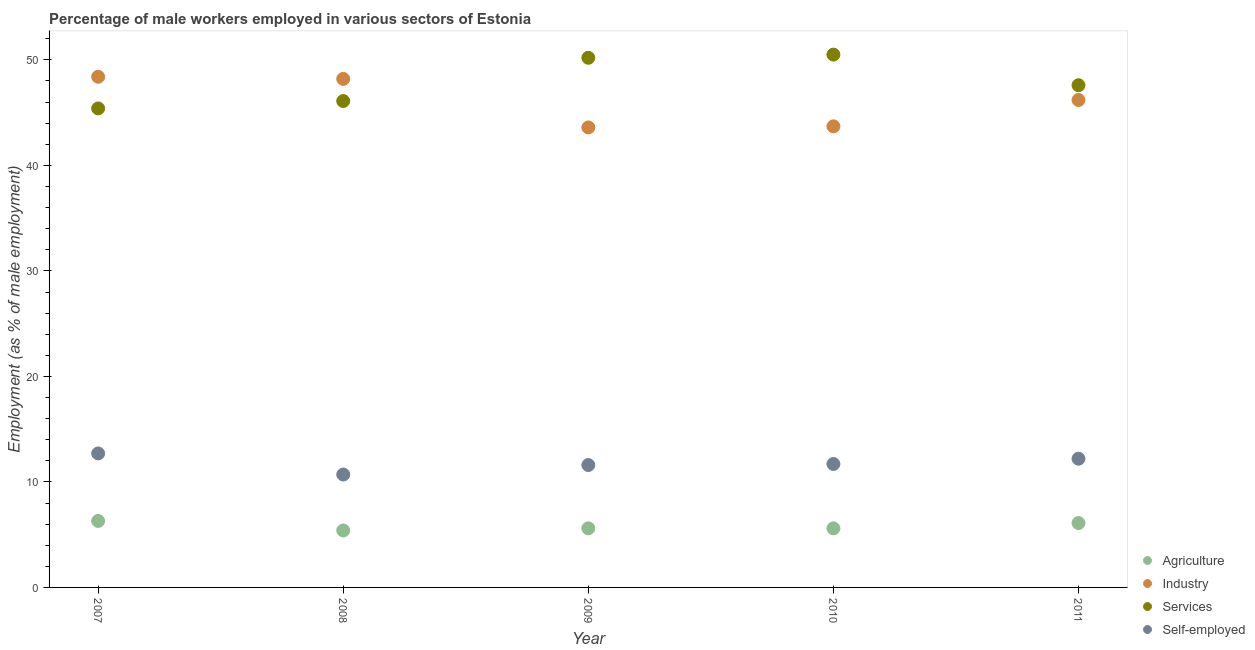Is the number of dotlines equal to the number of legend labels?
Offer a very short reply. Yes. What is the percentage of male workers in agriculture in 2007?
Provide a short and direct response. 6.3. Across all years, what is the maximum percentage of male workers in services?
Make the answer very short. 50.5. Across all years, what is the minimum percentage of male workers in services?
Ensure brevity in your answer.  45.4. What is the total percentage of self employed male workers in the graph?
Keep it short and to the point. 58.9. What is the difference between the percentage of male workers in agriculture in 2008 and that in 2010?
Provide a succinct answer. -0.2. What is the difference between the percentage of male workers in industry in 2010 and the percentage of male workers in services in 2009?
Keep it short and to the point. -6.5. What is the average percentage of male workers in services per year?
Keep it short and to the point. 47.96. In the year 2007, what is the difference between the percentage of male workers in agriculture and percentage of self employed male workers?
Offer a terse response. -6.4. In how many years, is the percentage of male workers in industry greater than 38 %?
Provide a succinct answer. 5. What is the ratio of the percentage of male workers in agriculture in 2010 to that in 2011?
Provide a short and direct response. 0.92. What is the difference between the highest and the second highest percentage of male workers in agriculture?
Give a very brief answer. 0.2. What is the difference between the highest and the lowest percentage of male workers in industry?
Keep it short and to the point. 4.8. Is the sum of the percentage of male workers in services in 2007 and 2008 greater than the maximum percentage of male workers in agriculture across all years?
Offer a terse response. Yes. Is it the case that in every year, the sum of the percentage of male workers in services and percentage of male workers in agriculture is greater than the sum of percentage of self employed male workers and percentage of male workers in industry?
Keep it short and to the point. Yes. Does the percentage of male workers in services monotonically increase over the years?
Offer a very short reply. No. How many dotlines are there?
Your answer should be compact. 4. How many years are there in the graph?
Give a very brief answer. 5. What is the difference between two consecutive major ticks on the Y-axis?
Ensure brevity in your answer.  10. Does the graph contain grids?
Your response must be concise. No. Where does the legend appear in the graph?
Your answer should be compact. Bottom right. How many legend labels are there?
Keep it short and to the point. 4. What is the title of the graph?
Offer a terse response. Percentage of male workers employed in various sectors of Estonia. Does "Quality of public administration" appear as one of the legend labels in the graph?
Provide a succinct answer. No. What is the label or title of the X-axis?
Provide a short and direct response. Year. What is the label or title of the Y-axis?
Your response must be concise. Employment (as % of male employment). What is the Employment (as % of male employment) in Agriculture in 2007?
Offer a terse response. 6.3. What is the Employment (as % of male employment) of Industry in 2007?
Provide a short and direct response. 48.4. What is the Employment (as % of male employment) of Services in 2007?
Make the answer very short. 45.4. What is the Employment (as % of male employment) in Self-employed in 2007?
Keep it short and to the point. 12.7. What is the Employment (as % of male employment) of Agriculture in 2008?
Offer a very short reply. 5.4. What is the Employment (as % of male employment) of Industry in 2008?
Provide a short and direct response. 48.2. What is the Employment (as % of male employment) in Services in 2008?
Make the answer very short. 46.1. What is the Employment (as % of male employment) of Self-employed in 2008?
Provide a short and direct response. 10.7. What is the Employment (as % of male employment) of Agriculture in 2009?
Your answer should be compact. 5.6. What is the Employment (as % of male employment) in Industry in 2009?
Give a very brief answer. 43.6. What is the Employment (as % of male employment) in Services in 2009?
Your answer should be compact. 50.2. What is the Employment (as % of male employment) in Self-employed in 2009?
Provide a succinct answer. 11.6. What is the Employment (as % of male employment) in Agriculture in 2010?
Your answer should be compact. 5.6. What is the Employment (as % of male employment) of Industry in 2010?
Offer a terse response. 43.7. What is the Employment (as % of male employment) in Services in 2010?
Provide a succinct answer. 50.5. What is the Employment (as % of male employment) in Self-employed in 2010?
Give a very brief answer. 11.7. What is the Employment (as % of male employment) in Agriculture in 2011?
Your response must be concise. 6.1. What is the Employment (as % of male employment) in Industry in 2011?
Your answer should be very brief. 46.2. What is the Employment (as % of male employment) in Services in 2011?
Your answer should be very brief. 47.6. What is the Employment (as % of male employment) of Self-employed in 2011?
Give a very brief answer. 12.2. Across all years, what is the maximum Employment (as % of male employment) in Agriculture?
Make the answer very short. 6.3. Across all years, what is the maximum Employment (as % of male employment) in Industry?
Your answer should be compact. 48.4. Across all years, what is the maximum Employment (as % of male employment) of Services?
Offer a very short reply. 50.5. Across all years, what is the maximum Employment (as % of male employment) of Self-employed?
Provide a succinct answer. 12.7. Across all years, what is the minimum Employment (as % of male employment) of Agriculture?
Provide a succinct answer. 5.4. Across all years, what is the minimum Employment (as % of male employment) of Industry?
Your response must be concise. 43.6. Across all years, what is the minimum Employment (as % of male employment) in Services?
Keep it short and to the point. 45.4. Across all years, what is the minimum Employment (as % of male employment) in Self-employed?
Provide a succinct answer. 10.7. What is the total Employment (as % of male employment) of Agriculture in the graph?
Ensure brevity in your answer.  29. What is the total Employment (as % of male employment) in Industry in the graph?
Give a very brief answer. 230.1. What is the total Employment (as % of male employment) in Services in the graph?
Make the answer very short. 239.8. What is the total Employment (as % of male employment) of Self-employed in the graph?
Ensure brevity in your answer.  58.9. What is the difference between the Employment (as % of male employment) in Agriculture in 2007 and that in 2008?
Your answer should be very brief. 0.9. What is the difference between the Employment (as % of male employment) in Industry in 2007 and that in 2008?
Your answer should be compact. 0.2. What is the difference between the Employment (as % of male employment) of Self-employed in 2007 and that in 2010?
Keep it short and to the point. 1. What is the difference between the Employment (as % of male employment) of Industry in 2007 and that in 2011?
Your response must be concise. 2.2. What is the difference between the Employment (as % of male employment) of Industry in 2008 and that in 2009?
Offer a terse response. 4.6. What is the difference between the Employment (as % of male employment) of Industry in 2008 and that in 2010?
Offer a very short reply. 4.5. What is the difference between the Employment (as % of male employment) of Services in 2008 and that in 2010?
Provide a short and direct response. -4.4. What is the difference between the Employment (as % of male employment) in Self-employed in 2008 and that in 2010?
Your answer should be very brief. -1. What is the difference between the Employment (as % of male employment) of Agriculture in 2008 and that in 2011?
Offer a very short reply. -0.7. What is the difference between the Employment (as % of male employment) in Services in 2008 and that in 2011?
Provide a succinct answer. -1.5. What is the difference between the Employment (as % of male employment) in Agriculture in 2009 and that in 2010?
Provide a short and direct response. 0. What is the difference between the Employment (as % of male employment) in Industry in 2009 and that in 2010?
Provide a short and direct response. -0.1. What is the difference between the Employment (as % of male employment) of Services in 2009 and that in 2010?
Your response must be concise. -0.3. What is the difference between the Employment (as % of male employment) in Agriculture in 2009 and that in 2011?
Your answer should be compact. -0.5. What is the difference between the Employment (as % of male employment) in Industry in 2009 and that in 2011?
Provide a short and direct response. -2.6. What is the difference between the Employment (as % of male employment) of Self-employed in 2010 and that in 2011?
Make the answer very short. -0.5. What is the difference between the Employment (as % of male employment) of Agriculture in 2007 and the Employment (as % of male employment) of Industry in 2008?
Offer a terse response. -41.9. What is the difference between the Employment (as % of male employment) of Agriculture in 2007 and the Employment (as % of male employment) of Services in 2008?
Provide a short and direct response. -39.8. What is the difference between the Employment (as % of male employment) in Agriculture in 2007 and the Employment (as % of male employment) in Self-employed in 2008?
Give a very brief answer. -4.4. What is the difference between the Employment (as % of male employment) of Industry in 2007 and the Employment (as % of male employment) of Services in 2008?
Provide a succinct answer. 2.3. What is the difference between the Employment (as % of male employment) of Industry in 2007 and the Employment (as % of male employment) of Self-employed in 2008?
Give a very brief answer. 37.7. What is the difference between the Employment (as % of male employment) in Services in 2007 and the Employment (as % of male employment) in Self-employed in 2008?
Ensure brevity in your answer.  34.7. What is the difference between the Employment (as % of male employment) in Agriculture in 2007 and the Employment (as % of male employment) in Industry in 2009?
Ensure brevity in your answer.  -37.3. What is the difference between the Employment (as % of male employment) in Agriculture in 2007 and the Employment (as % of male employment) in Services in 2009?
Keep it short and to the point. -43.9. What is the difference between the Employment (as % of male employment) of Agriculture in 2007 and the Employment (as % of male employment) of Self-employed in 2009?
Your answer should be very brief. -5.3. What is the difference between the Employment (as % of male employment) of Industry in 2007 and the Employment (as % of male employment) of Self-employed in 2009?
Provide a succinct answer. 36.8. What is the difference between the Employment (as % of male employment) of Services in 2007 and the Employment (as % of male employment) of Self-employed in 2009?
Your answer should be compact. 33.8. What is the difference between the Employment (as % of male employment) of Agriculture in 2007 and the Employment (as % of male employment) of Industry in 2010?
Your response must be concise. -37.4. What is the difference between the Employment (as % of male employment) in Agriculture in 2007 and the Employment (as % of male employment) in Services in 2010?
Make the answer very short. -44.2. What is the difference between the Employment (as % of male employment) of Agriculture in 2007 and the Employment (as % of male employment) of Self-employed in 2010?
Your answer should be compact. -5.4. What is the difference between the Employment (as % of male employment) in Industry in 2007 and the Employment (as % of male employment) in Services in 2010?
Give a very brief answer. -2.1. What is the difference between the Employment (as % of male employment) in Industry in 2007 and the Employment (as % of male employment) in Self-employed in 2010?
Offer a very short reply. 36.7. What is the difference between the Employment (as % of male employment) of Services in 2007 and the Employment (as % of male employment) of Self-employed in 2010?
Offer a very short reply. 33.7. What is the difference between the Employment (as % of male employment) in Agriculture in 2007 and the Employment (as % of male employment) in Industry in 2011?
Keep it short and to the point. -39.9. What is the difference between the Employment (as % of male employment) in Agriculture in 2007 and the Employment (as % of male employment) in Services in 2011?
Offer a very short reply. -41.3. What is the difference between the Employment (as % of male employment) of Industry in 2007 and the Employment (as % of male employment) of Services in 2011?
Provide a succinct answer. 0.8. What is the difference between the Employment (as % of male employment) of Industry in 2007 and the Employment (as % of male employment) of Self-employed in 2011?
Your answer should be compact. 36.2. What is the difference between the Employment (as % of male employment) of Services in 2007 and the Employment (as % of male employment) of Self-employed in 2011?
Make the answer very short. 33.2. What is the difference between the Employment (as % of male employment) in Agriculture in 2008 and the Employment (as % of male employment) in Industry in 2009?
Make the answer very short. -38.2. What is the difference between the Employment (as % of male employment) in Agriculture in 2008 and the Employment (as % of male employment) in Services in 2009?
Provide a short and direct response. -44.8. What is the difference between the Employment (as % of male employment) in Agriculture in 2008 and the Employment (as % of male employment) in Self-employed in 2009?
Your answer should be compact. -6.2. What is the difference between the Employment (as % of male employment) of Industry in 2008 and the Employment (as % of male employment) of Self-employed in 2009?
Make the answer very short. 36.6. What is the difference between the Employment (as % of male employment) in Services in 2008 and the Employment (as % of male employment) in Self-employed in 2009?
Make the answer very short. 34.5. What is the difference between the Employment (as % of male employment) of Agriculture in 2008 and the Employment (as % of male employment) of Industry in 2010?
Your answer should be very brief. -38.3. What is the difference between the Employment (as % of male employment) in Agriculture in 2008 and the Employment (as % of male employment) in Services in 2010?
Provide a succinct answer. -45.1. What is the difference between the Employment (as % of male employment) in Agriculture in 2008 and the Employment (as % of male employment) in Self-employed in 2010?
Your answer should be very brief. -6.3. What is the difference between the Employment (as % of male employment) in Industry in 2008 and the Employment (as % of male employment) in Services in 2010?
Make the answer very short. -2.3. What is the difference between the Employment (as % of male employment) of Industry in 2008 and the Employment (as % of male employment) of Self-employed in 2010?
Your answer should be compact. 36.5. What is the difference between the Employment (as % of male employment) in Services in 2008 and the Employment (as % of male employment) in Self-employed in 2010?
Offer a terse response. 34.4. What is the difference between the Employment (as % of male employment) of Agriculture in 2008 and the Employment (as % of male employment) of Industry in 2011?
Provide a short and direct response. -40.8. What is the difference between the Employment (as % of male employment) of Agriculture in 2008 and the Employment (as % of male employment) of Services in 2011?
Your answer should be compact. -42.2. What is the difference between the Employment (as % of male employment) of Agriculture in 2008 and the Employment (as % of male employment) of Self-employed in 2011?
Keep it short and to the point. -6.8. What is the difference between the Employment (as % of male employment) of Industry in 2008 and the Employment (as % of male employment) of Services in 2011?
Provide a short and direct response. 0.6. What is the difference between the Employment (as % of male employment) of Services in 2008 and the Employment (as % of male employment) of Self-employed in 2011?
Your response must be concise. 33.9. What is the difference between the Employment (as % of male employment) in Agriculture in 2009 and the Employment (as % of male employment) in Industry in 2010?
Keep it short and to the point. -38.1. What is the difference between the Employment (as % of male employment) of Agriculture in 2009 and the Employment (as % of male employment) of Services in 2010?
Ensure brevity in your answer.  -44.9. What is the difference between the Employment (as % of male employment) in Industry in 2009 and the Employment (as % of male employment) in Services in 2010?
Your response must be concise. -6.9. What is the difference between the Employment (as % of male employment) of Industry in 2009 and the Employment (as % of male employment) of Self-employed in 2010?
Ensure brevity in your answer.  31.9. What is the difference between the Employment (as % of male employment) of Services in 2009 and the Employment (as % of male employment) of Self-employed in 2010?
Make the answer very short. 38.5. What is the difference between the Employment (as % of male employment) in Agriculture in 2009 and the Employment (as % of male employment) in Industry in 2011?
Ensure brevity in your answer.  -40.6. What is the difference between the Employment (as % of male employment) of Agriculture in 2009 and the Employment (as % of male employment) of Services in 2011?
Provide a short and direct response. -42. What is the difference between the Employment (as % of male employment) in Agriculture in 2009 and the Employment (as % of male employment) in Self-employed in 2011?
Your answer should be compact. -6.6. What is the difference between the Employment (as % of male employment) of Industry in 2009 and the Employment (as % of male employment) of Self-employed in 2011?
Offer a very short reply. 31.4. What is the difference between the Employment (as % of male employment) of Services in 2009 and the Employment (as % of male employment) of Self-employed in 2011?
Your answer should be very brief. 38. What is the difference between the Employment (as % of male employment) of Agriculture in 2010 and the Employment (as % of male employment) of Industry in 2011?
Your answer should be very brief. -40.6. What is the difference between the Employment (as % of male employment) in Agriculture in 2010 and the Employment (as % of male employment) in Services in 2011?
Your answer should be very brief. -42. What is the difference between the Employment (as % of male employment) of Agriculture in 2010 and the Employment (as % of male employment) of Self-employed in 2011?
Your answer should be very brief. -6.6. What is the difference between the Employment (as % of male employment) in Industry in 2010 and the Employment (as % of male employment) in Services in 2011?
Give a very brief answer. -3.9. What is the difference between the Employment (as % of male employment) of Industry in 2010 and the Employment (as % of male employment) of Self-employed in 2011?
Provide a short and direct response. 31.5. What is the difference between the Employment (as % of male employment) of Services in 2010 and the Employment (as % of male employment) of Self-employed in 2011?
Keep it short and to the point. 38.3. What is the average Employment (as % of male employment) of Agriculture per year?
Keep it short and to the point. 5.8. What is the average Employment (as % of male employment) in Industry per year?
Make the answer very short. 46.02. What is the average Employment (as % of male employment) in Services per year?
Your response must be concise. 47.96. What is the average Employment (as % of male employment) of Self-employed per year?
Offer a very short reply. 11.78. In the year 2007, what is the difference between the Employment (as % of male employment) in Agriculture and Employment (as % of male employment) in Industry?
Provide a succinct answer. -42.1. In the year 2007, what is the difference between the Employment (as % of male employment) of Agriculture and Employment (as % of male employment) of Services?
Give a very brief answer. -39.1. In the year 2007, what is the difference between the Employment (as % of male employment) in Industry and Employment (as % of male employment) in Services?
Offer a very short reply. 3. In the year 2007, what is the difference between the Employment (as % of male employment) in Industry and Employment (as % of male employment) in Self-employed?
Your answer should be very brief. 35.7. In the year 2007, what is the difference between the Employment (as % of male employment) of Services and Employment (as % of male employment) of Self-employed?
Offer a terse response. 32.7. In the year 2008, what is the difference between the Employment (as % of male employment) in Agriculture and Employment (as % of male employment) in Industry?
Offer a very short reply. -42.8. In the year 2008, what is the difference between the Employment (as % of male employment) in Agriculture and Employment (as % of male employment) in Services?
Offer a terse response. -40.7. In the year 2008, what is the difference between the Employment (as % of male employment) in Agriculture and Employment (as % of male employment) in Self-employed?
Offer a very short reply. -5.3. In the year 2008, what is the difference between the Employment (as % of male employment) in Industry and Employment (as % of male employment) in Self-employed?
Offer a terse response. 37.5. In the year 2008, what is the difference between the Employment (as % of male employment) in Services and Employment (as % of male employment) in Self-employed?
Offer a terse response. 35.4. In the year 2009, what is the difference between the Employment (as % of male employment) of Agriculture and Employment (as % of male employment) of Industry?
Ensure brevity in your answer.  -38. In the year 2009, what is the difference between the Employment (as % of male employment) of Agriculture and Employment (as % of male employment) of Services?
Provide a succinct answer. -44.6. In the year 2009, what is the difference between the Employment (as % of male employment) of Agriculture and Employment (as % of male employment) of Self-employed?
Keep it short and to the point. -6. In the year 2009, what is the difference between the Employment (as % of male employment) in Industry and Employment (as % of male employment) in Services?
Keep it short and to the point. -6.6. In the year 2009, what is the difference between the Employment (as % of male employment) of Industry and Employment (as % of male employment) of Self-employed?
Your answer should be compact. 32. In the year 2009, what is the difference between the Employment (as % of male employment) of Services and Employment (as % of male employment) of Self-employed?
Offer a very short reply. 38.6. In the year 2010, what is the difference between the Employment (as % of male employment) of Agriculture and Employment (as % of male employment) of Industry?
Keep it short and to the point. -38.1. In the year 2010, what is the difference between the Employment (as % of male employment) of Agriculture and Employment (as % of male employment) of Services?
Your answer should be compact. -44.9. In the year 2010, what is the difference between the Employment (as % of male employment) in Services and Employment (as % of male employment) in Self-employed?
Your response must be concise. 38.8. In the year 2011, what is the difference between the Employment (as % of male employment) of Agriculture and Employment (as % of male employment) of Industry?
Provide a short and direct response. -40.1. In the year 2011, what is the difference between the Employment (as % of male employment) in Agriculture and Employment (as % of male employment) in Services?
Make the answer very short. -41.5. In the year 2011, what is the difference between the Employment (as % of male employment) of Agriculture and Employment (as % of male employment) of Self-employed?
Your response must be concise. -6.1. In the year 2011, what is the difference between the Employment (as % of male employment) of Industry and Employment (as % of male employment) of Services?
Keep it short and to the point. -1.4. In the year 2011, what is the difference between the Employment (as % of male employment) in Industry and Employment (as % of male employment) in Self-employed?
Your answer should be compact. 34. In the year 2011, what is the difference between the Employment (as % of male employment) of Services and Employment (as % of male employment) of Self-employed?
Your answer should be very brief. 35.4. What is the ratio of the Employment (as % of male employment) of Self-employed in 2007 to that in 2008?
Keep it short and to the point. 1.19. What is the ratio of the Employment (as % of male employment) in Industry in 2007 to that in 2009?
Offer a terse response. 1.11. What is the ratio of the Employment (as % of male employment) of Services in 2007 to that in 2009?
Offer a very short reply. 0.9. What is the ratio of the Employment (as % of male employment) in Self-employed in 2007 to that in 2009?
Your response must be concise. 1.09. What is the ratio of the Employment (as % of male employment) in Industry in 2007 to that in 2010?
Your answer should be compact. 1.11. What is the ratio of the Employment (as % of male employment) in Services in 2007 to that in 2010?
Keep it short and to the point. 0.9. What is the ratio of the Employment (as % of male employment) in Self-employed in 2007 to that in 2010?
Offer a very short reply. 1.09. What is the ratio of the Employment (as % of male employment) in Agriculture in 2007 to that in 2011?
Your answer should be compact. 1.03. What is the ratio of the Employment (as % of male employment) in Industry in 2007 to that in 2011?
Your response must be concise. 1.05. What is the ratio of the Employment (as % of male employment) in Services in 2007 to that in 2011?
Make the answer very short. 0.95. What is the ratio of the Employment (as % of male employment) of Self-employed in 2007 to that in 2011?
Offer a very short reply. 1.04. What is the ratio of the Employment (as % of male employment) in Industry in 2008 to that in 2009?
Ensure brevity in your answer.  1.11. What is the ratio of the Employment (as % of male employment) in Services in 2008 to that in 2009?
Your answer should be compact. 0.92. What is the ratio of the Employment (as % of male employment) in Self-employed in 2008 to that in 2009?
Your answer should be compact. 0.92. What is the ratio of the Employment (as % of male employment) of Industry in 2008 to that in 2010?
Make the answer very short. 1.1. What is the ratio of the Employment (as % of male employment) of Services in 2008 to that in 2010?
Give a very brief answer. 0.91. What is the ratio of the Employment (as % of male employment) in Self-employed in 2008 to that in 2010?
Offer a terse response. 0.91. What is the ratio of the Employment (as % of male employment) of Agriculture in 2008 to that in 2011?
Ensure brevity in your answer.  0.89. What is the ratio of the Employment (as % of male employment) of Industry in 2008 to that in 2011?
Your answer should be compact. 1.04. What is the ratio of the Employment (as % of male employment) of Services in 2008 to that in 2011?
Your answer should be compact. 0.97. What is the ratio of the Employment (as % of male employment) in Self-employed in 2008 to that in 2011?
Your answer should be compact. 0.88. What is the ratio of the Employment (as % of male employment) in Agriculture in 2009 to that in 2010?
Offer a terse response. 1. What is the ratio of the Employment (as % of male employment) in Industry in 2009 to that in 2010?
Your response must be concise. 1. What is the ratio of the Employment (as % of male employment) of Services in 2009 to that in 2010?
Your answer should be very brief. 0.99. What is the ratio of the Employment (as % of male employment) in Agriculture in 2009 to that in 2011?
Your answer should be compact. 0.92. What is the ratio of the Employment (as % of male employment) in Industry in 2009 to that in 2011?
Provide a short and direct response. 0.94. What is the ratio of the Employment (as % of male employment) in Services in 2009 to that in 2011?
Your response must be concise. 1.05. What is the ratio of the Employment (as % of male employment) in Self-employed in 2009 to that in 2011?
Make the answer very short. 0.95. What is the ratio of the Employment (as % of male employment) of Agriculture in 2010 to that in 2011?
Ensure brevity in your answer.  0.92. What is the ratio of the Employment (as % of male employment) of Industry in 2010 to that in 2011?
Offer a very short reply. 0.95. What is the ratio of the Employment (as % of male employment) in Services in 2010 to that in 2011?
Provide a short and direct response. 1.06. What is the ratio of the Employment (as % of male employment) of Self-employed in 2010 to that in 2011?
Your answer should be compact. 0.96. What is the difference between the highest and the second highest Employment (as % of male employment) in Industry?
Your answer should be compact. 0.2. What is the difference between the highest and the second highest Employment (as % of male employment) of Services?
Make the answer very short. 0.3. What is the difference between the highest and the lowest Employment (as % of male employment) of Agriculture?
Offer a terse response. 0.9. What is the difference between the highest and the lowest Employment (as % of male employment) of Services?
Your response must be concise. 5.1. 